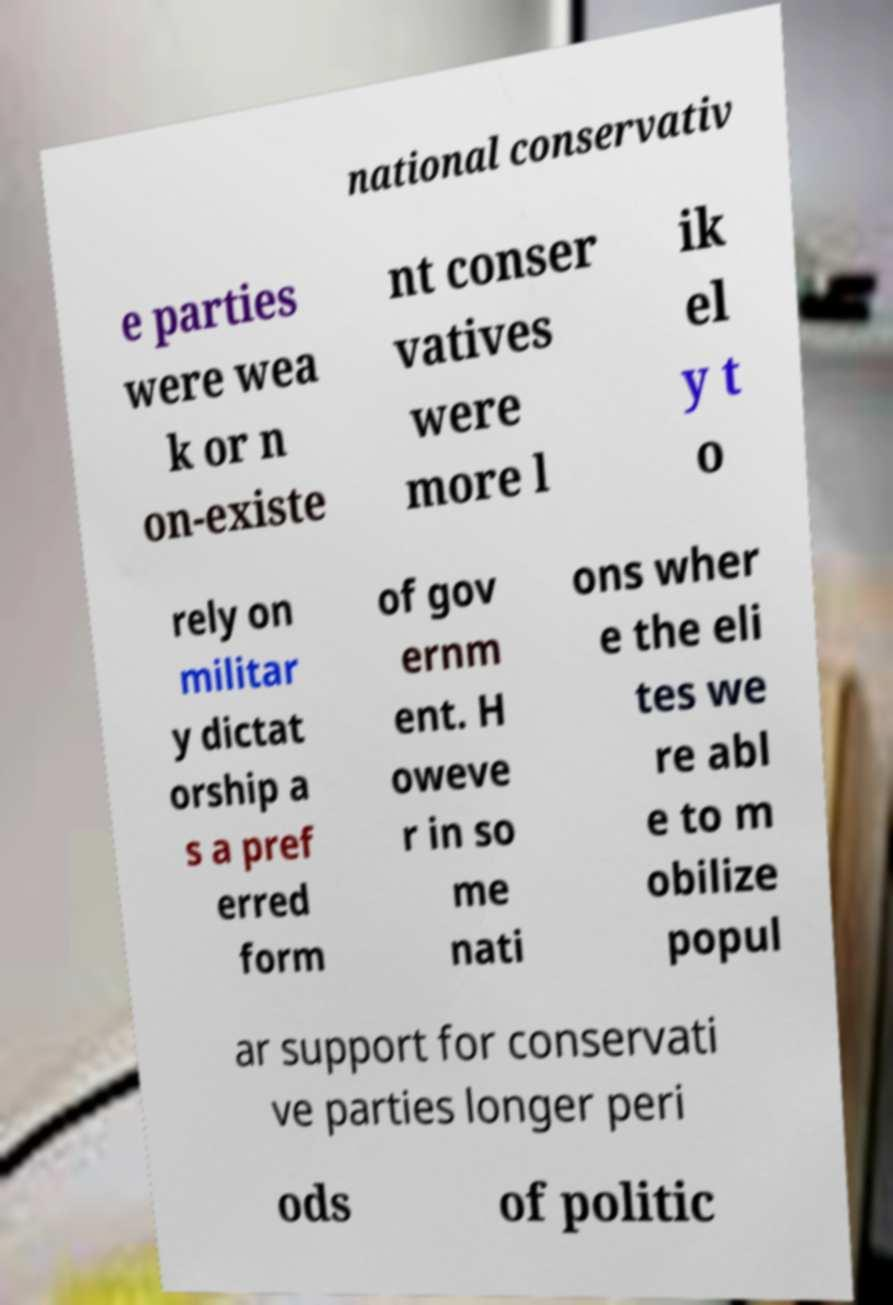There's text embedded in this image that I need extracted. Can you transcribe it verbatim? national conservativ e parties were wea k or n on-existe nt conser vatives were more l ik el y t o rely on militar y dictat orship a s a pref erred form of gov ernm ent. H oweve r in so me nati ons wher e the eli tes we re abl e to m obilize popul ar support for conservati ve parties longer peri ods of politic 